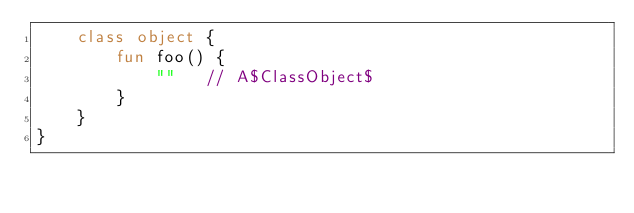<code> <loc_0><loc_0><loc_500><loc_500><_Kotlin_>    class object {
        fun foo() {
            ""   // A$ClassObject$
        }
    }
}
</code> 